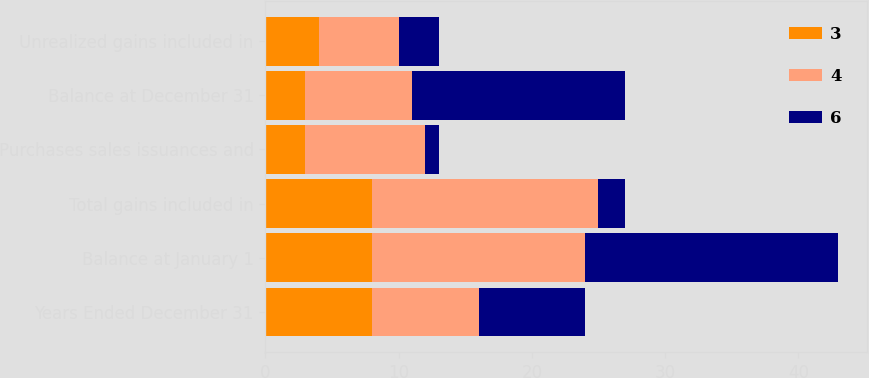<chart> <loc_0><loc_0><loc_500><loc_500><stacked_bar_chart><ecel><fcel>Years Ended December 31<fcel>Balance at January 1<fcel>Total gains included in<fcel>Purchases sales issuances and<fcel>Balance at December 31<fcel>Unrealized gains included in<nl><fcel>3<fcel>8<fcel>8<fcel>8<fcel>3<fcel>3<fcel>4<nl><fcel>4<fcel>8<fcel>16<fcel>17<fcel>9<fcel>8<fcel>6<nl><fcel>6<fcel>8<fcel>19<fcel>2<fcel>1<fcel>16<fcel>3<nl></chart> 